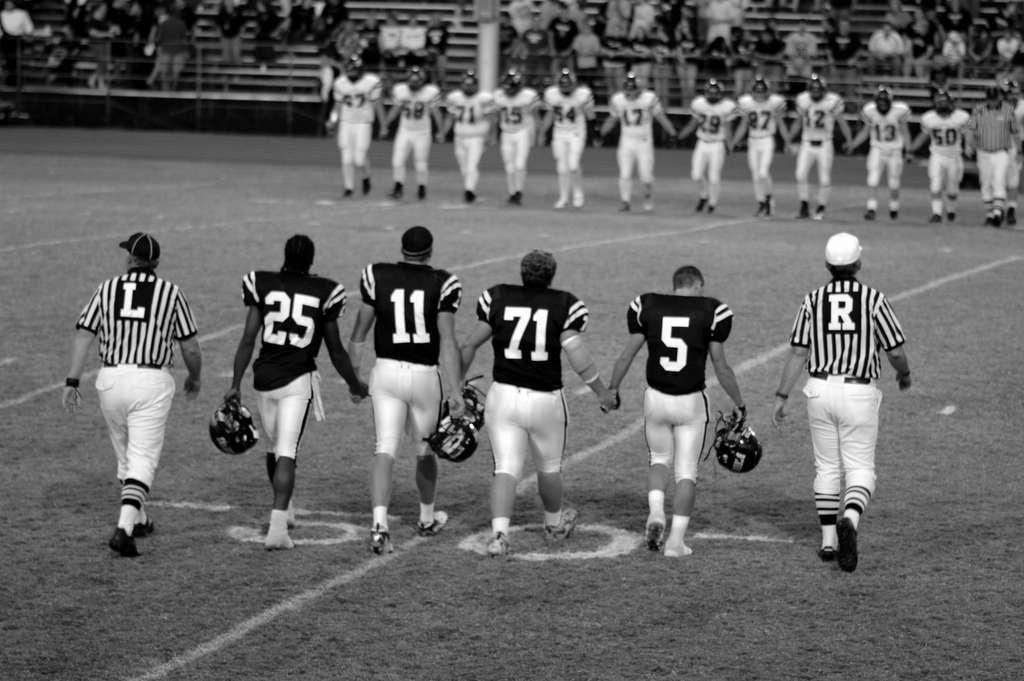<image>
Offer a succinct explanation of the picture presented. The players 25, 11, 71 and 5 walk hand in hand. 